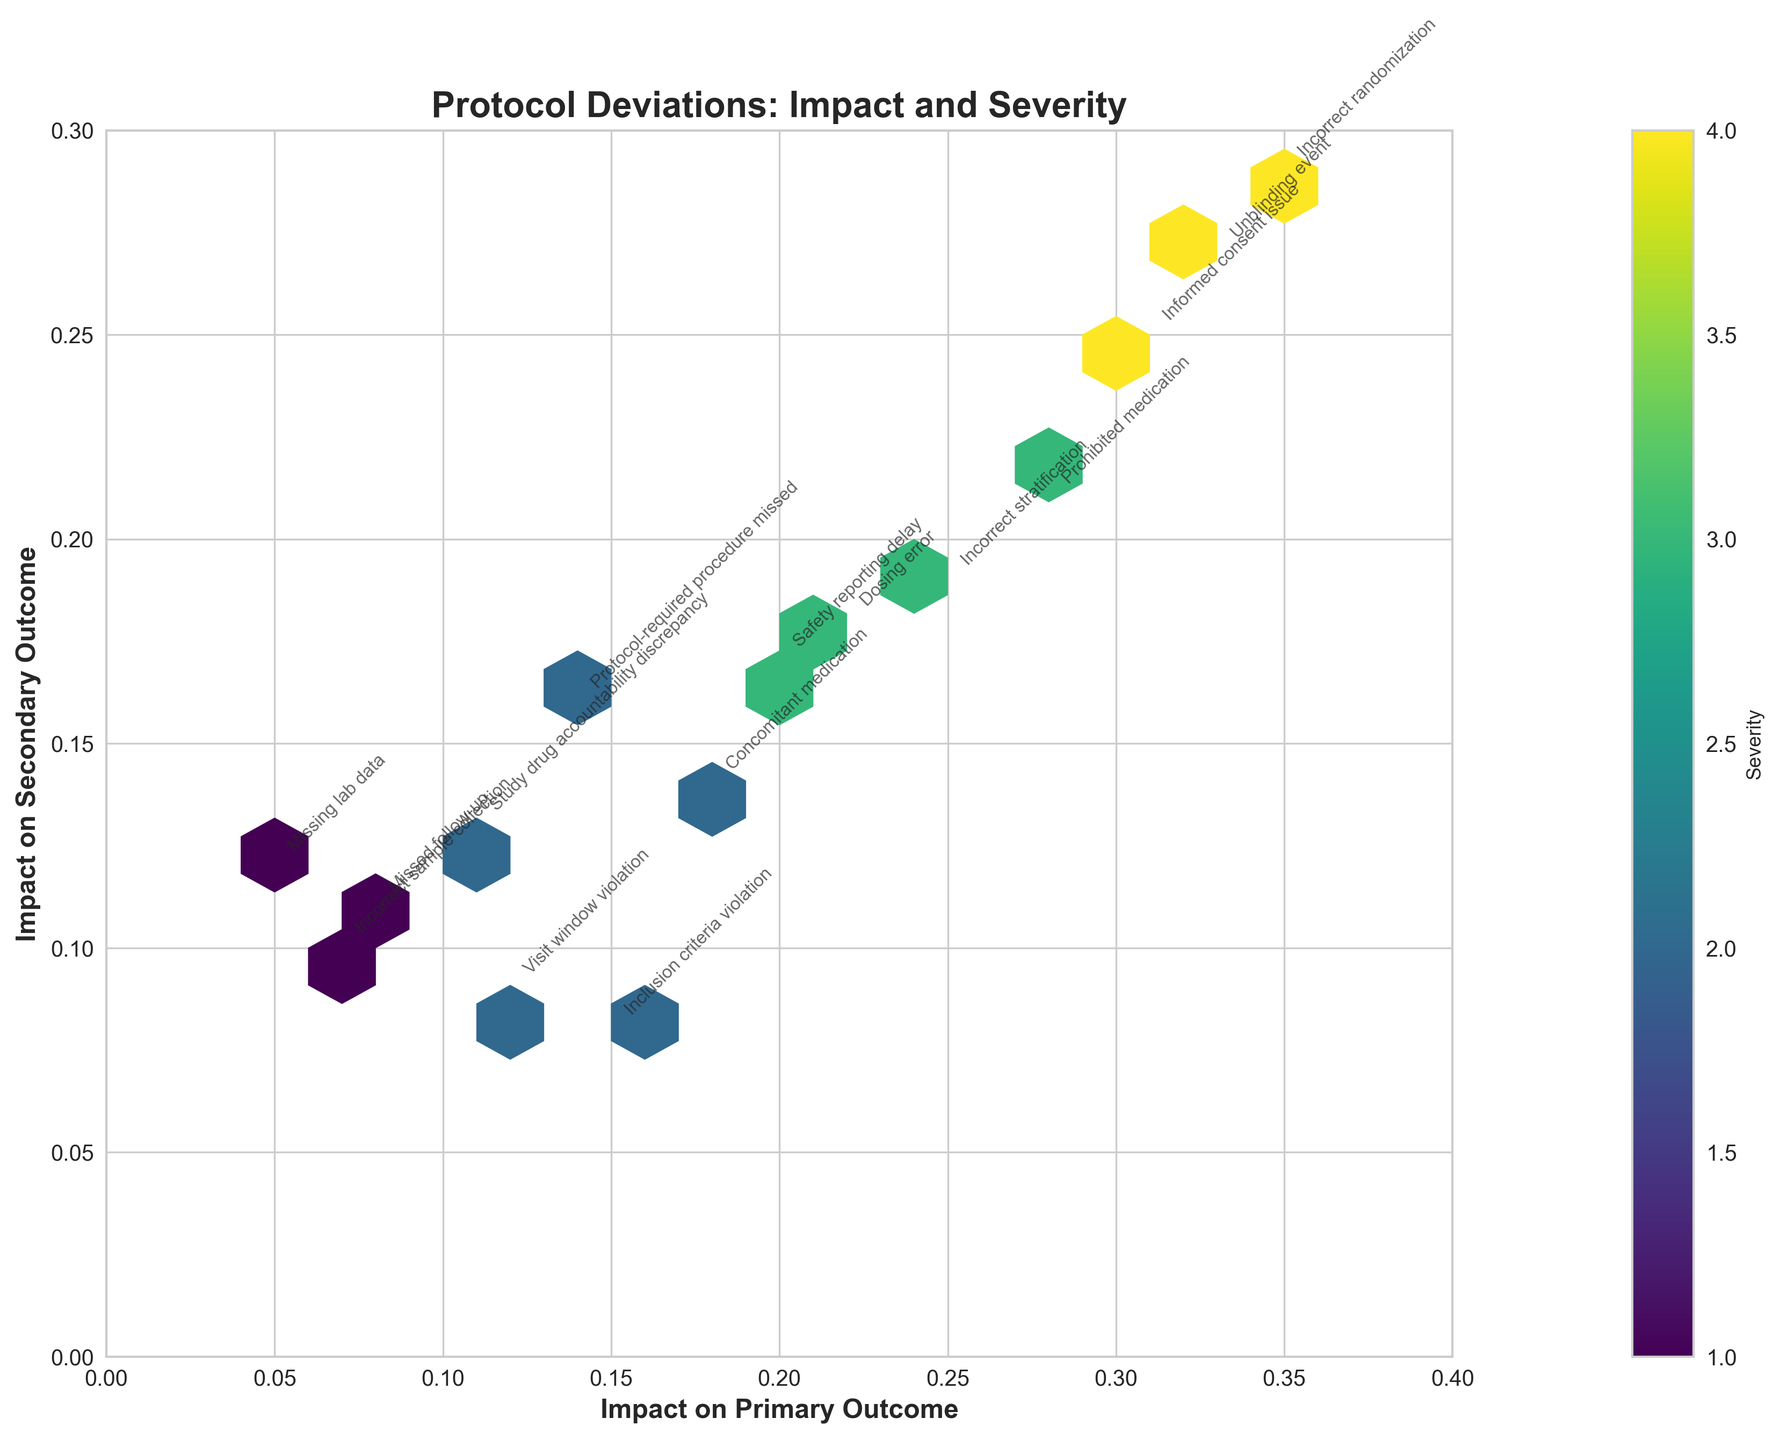What is the title of the plot? The plot's title is displayed at the top of the figure in bold font.
Answer: Protocol Deviations: Impact and Severity Which axis shows the impact on primary outcome measures? The x-axis label, written in bold, indicates the parameter displayed on this axis.
Answer: The x-axis How many protocol deviation types are labeled in the plot? Each type of protocol deviation is annotated next to their respective hexbin data point. Counting all these labels provides the answer.
Answer: 15 What is the most severe protocol deviation with the highest impact on primary outcome measures? Look for the annotated data point with the highest x-value and check its label. The color intensity would also be high due to greater severity.
Answer: Incorrect randomization Which protocol deviation has the lowest impact on both primary and secondary outcome measures? Identify the data point closest to the origin (0,0) and read its label.
Answer: Missing lab data What is the range of severity values displayed on the color bar? The color bar labeled "Severity" provides a visual range from the minimum to the maximum severity values used in the plot.
Answer: 1 to 4 Name two protocol deviations with a severity of 3 and compare their impact on secondary outcomes. Find the deviations with a color representing severity 3 and compare their y-values, indicating impact on secondary outcomes.
Answer: Dosing error has 0.18, Safety reporting delay has 0.17 Which deviation has the highest impact on secondary outcomes but relatively low primary outcome impact? Identify the data point with the highest y-value and check if its x-value is relatively low.
Answer: Unblinding event How does the impact of "Prohibited medication" on secondary outcome compare to "Concomitant medication"? Find both deviations and compare their y-values to determine which has a higher or lower secondary outcome impact.
Answer: Prohibited medication has 0.21; Concomitant medication has 0.14 What are the overall trends observed between severity and impact on primary and secondary outcomes? Observe the hexbin plot for any patterns of color intensity and the distribution along the x and y axes to deduce the trend.
Answer: Higher severity often corresponds to higher impacts 